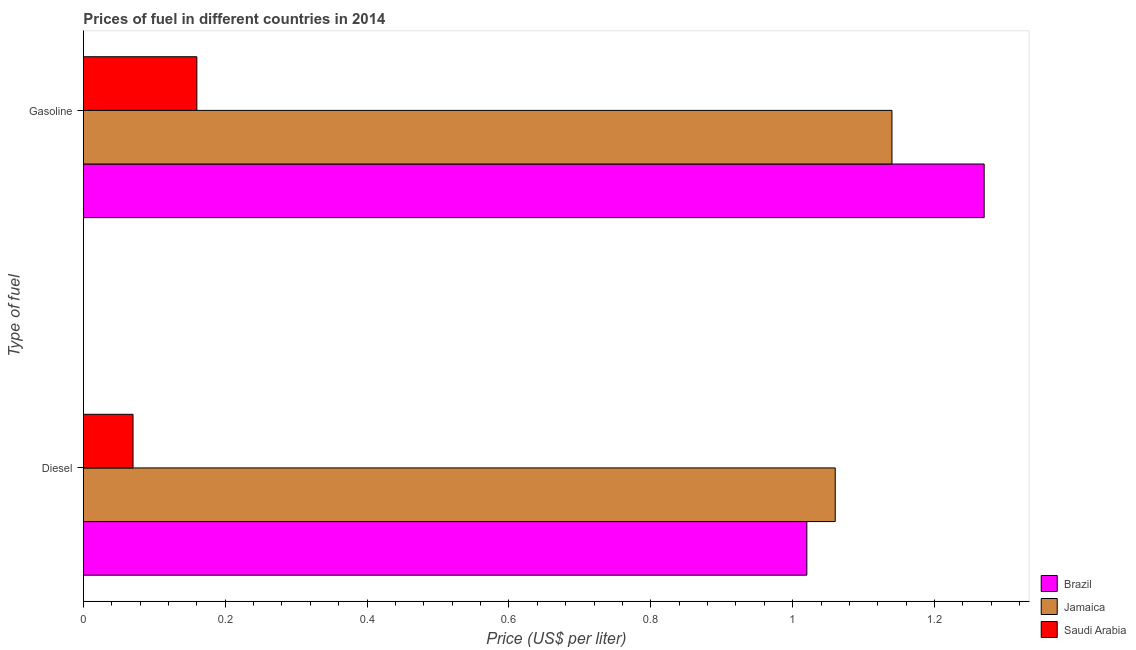How many groups of bars are there?
Make the answer very short. 2. Are the number of bars per tick equal to the number of legend labels?
Your answer should be very brief. Yes. Are the number of bars on each tick of the Y-axis equal?
Offer a terse response. Yes. How many bars are there on the 1st tick from the top?
Keep it short and to the point. 3. What is the label of the 2nd group of bars from the top?
Give a very brief answer. Diesel. What is the gasoline price in Brazil?
Give a very brief answer. 1.27. Across all countries, what is the maximum gasoline price?
Your response must be concise. 1.27. Across all countries, what is the minimum diesel price?
Your answer should be very brief. 0.07. In which country was the diesel price maximum?
Your answer should be very brief. Jamaica. In which country was the diesel price minimum?
Keep it short and to the point. Saudi Arabia. What is the total gasoline price in the graph?
Your answer should be very brief. 2.57. What is the difference between the diesel price in Brazil and that in Jamaica?
Give a very brief answer. -0.04. What is the difference between the diesel price in Brazil and the gasoline price in Saudi Arabia?
Offer a very short reply. 0.86. What is the average gasoline price per country?
Keep it short and to the point. 0.86. What is the difference between the gasoline price and diesel price in Saudi Arabia?
Keep it short and to the point. 0.09. What is the ratio of the gasoline price in Saudi Arabia to that in Brazil?
Keep it short and to the point. 0.13. What does the 2nd bar from the top in Diesel represents?
Keep it short and to the point. Jamaica. What does the 3rd bar from the bottom in Diesel represents?
Keep it short and to the point. Saudi Arabia. Are all the bars in the graph horizontal?
Give a very brief answer. Yes. How many countries are there in the graph?
Give a very brief answer. 3. What is the title of the graph?
Offer a very short reply. Prices of fuel in different countries in 2014. Does "Korea (Democratic)" appear as one of the legend labels in the graph?
Offer a terse response. No. What is the label or title of the X-axis?
Your answer should be compact. Price (US$ per liter). What is the label or title of the Y-axis?
Keep it short and to the point. Type of fuel. What is the Price (US$ per liter) of Jamaica in Diesel?
Give a very brief answer. 1.06. What is the Price (US$ per liter) of Saudi Arabia in Diesel?
Keep it short and to the point. 0.07. What is the Price (US$ per liter) of Brazil in Gasoline?
Keep it short and to the point. 1.27. What is the Price (US$ per liter) of Jamaica in Gasoline?
Keep it short and to the point. 1.14. What is the Price (US$ per liter) of Saudi Arabia in Gasoline?
Keep it short and to the point. 0.16. Across all Type of fuel, what is the maximum Price (US$ per liter) in Brazil?
Keep it short and to the point. 1.27. Across all Type of fuel, what is the maximum Price (US$ per liter) in Jamaica?
Provide a succinct answer. 1.14. Across all Type of fuel, what is the maximum Price (US$ per liter) in Saudi Arabia?
Keep it short and to the point. 0.16. Across all Type of fuel, what is the minimum Price (US$ per liter) of Jamaica?
Ensure brevity in your answer.  1.06. Across all Type of fuel, what is the minimum Price (US$ per liter) in Saudi Arabia?
Your response must be concise. 0.07. What is the total Price (US$ per liter) in Brazil in the graph?
Give a very brief answer. 2.29. What is the total Price (US$ per liter) in Saudi Arabia in the graph?
Make the answer very short. 0.23. What is the difference between the Price (US$ per liter) of Brazil in Diesel and that in Gasoline?
Keep it short and to the point. -0.25. What is the difference between the Price (US$ per liter) in Jamaica in Diesel and that in Gasoline?
Your response must be concise. -0.08. What is the difference between the Price (US$ per liter) of Saudi Arabia in Diesel and that in Gasoline?
Make the answer very short. -0.09. What is the difference between the Price (US$ per liter) of Brazil in Diesel and the Price (US$ per liter) of Jamaica in Gasoline?
Offer a terse response. -0.12. What is the difference between the Price (US$ per liter) in Brazil in Diesel and the Price (US$ per liter) in Saudi Arabia in Gasoline?
Offer a very short reply. 0.86. What is the difference between the Price (US$ per liter) of Jamaica in Diesel and the Price (US$ per liter) of Saudi Arabia in Gasoline?
Your response must be concise. 0.9. What is the average Price (US$ per liter) of Brazil per Type of fuel?
Offer a terse response. 1.15. What is the average Price (US$ per liter) of Jamaica per Type of fuel?
Offer a very short reply. 1.1. What is the average Price (US$ per liter) in Saudi Arabia per Type of fuel?
Your response must be concise. 0.12. What is the difference between the Price (US$ per liter) of Brazil and Price (US$ per liter) of Jamaica in Diesel?
Provide a short and direct response. -0.04. What is the difference between the Price (US$ per liter) in Brazil and Price (US$ per liter) in Saudi Arabia in Diesel?
Make the answer very short. 0.95. What is the difference between the Price (US$ per liter) of Brazil and Price (US$ per liter) of Jamaica in Gasoline?
Your response must be concise. 0.13. What is the difference between the Price (US$ per liter) of Brazil and Price (US$ per liter) of Saudi Arabia in Gasoline?
Provide a short and direct response. 1.11. What is the ratio of the Price (US$ per liter) of Brazil in Diesel to that in Gasoline?
Provide a succinct answer. 0.8. What is the ratio of the Price (US$ per liter) in Jamaica in Diesel to that in Gasoline?
Offer a terse response. 0.93. What is the ratio of the Price (US$ per liter) in Saudi Arabia in Diesel to that in Gasoline?
Ensure brevity in your answer.  0.44. What is the difference between the highest and the second highest Price (US$ per liter) of Brazil?
Your answer should be compact. 0.25. What is the difference between the highest and the second highest Price (US$ per liter) of Saudi Arabia?
Keep it short and to the point. 0.09. What is the difference between the highest and the lowest Price (US$ per liter) of Saudi Arabia?
Provide a succinct answer. 0.09. 